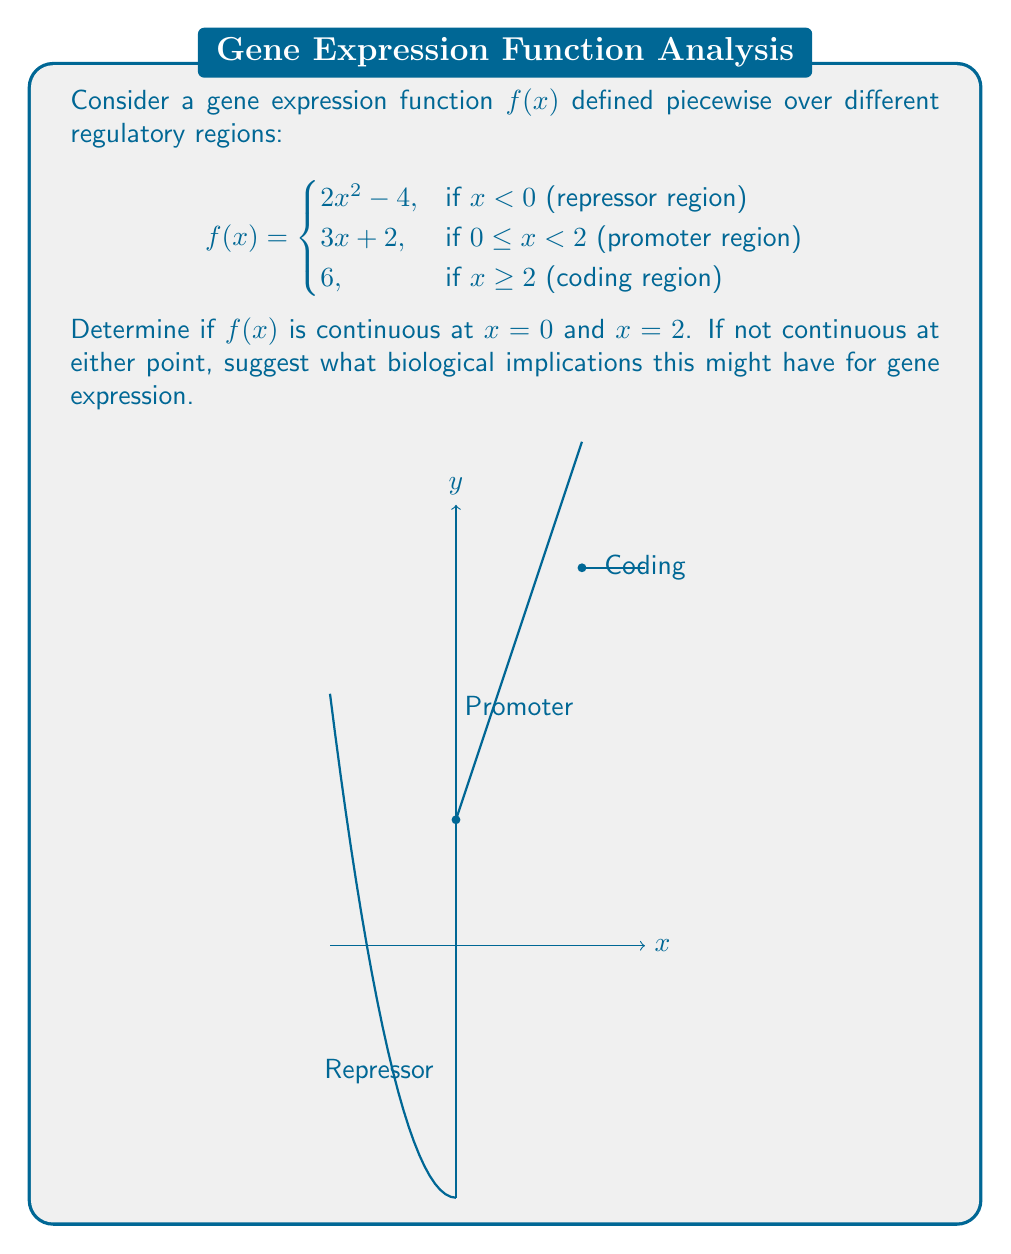Give your solution to this math problem. To determine continuity at $x = 0$ and $x = 2$, we need to check three conditions at each point:
1. The function is defined at the point
2. The limit of the function exists as we approach the point from both sides
3. The limit equals the function value at that point

For $x = 0$:
1. $f(0)$ is defined: $f(0) = 3(0) + 2 = 2$
2. Left limit: $\lim_{x \to 0^-} f(x) = \lim_{x \to 0^-} (2x^2 - 4) = -4$
   Right limit: $\lim_{x \to 0^+} f(x) = \lim_{x \to 0^+} (3x + 2) = 2$
3. The left limit $\neq$ right limit, so the limit doesn't exist at $x = 0$

Therefore, $f(x)$ is not continuous at $x = 0$.

For $x = 2$:
1. $f(2)$ is defined: $f(2) = 6$
2. Left limit: $\lim_{x \to 2^-} f(x) = \lim_{x \to 2^-} (3x + 2) = 8$
   Right limit: $\lim_{x \to 2^+} f(x) = \lim_{x \to 2^+} 6 = 6$
3. The left limit $\neq$ right limit, so the limit doesn't exist at $x = 2$

Therefore, $f(x)$ is not continuous at $x = 2$.

Biological implications:
The discontinuity at $x = 0$ suggests an abrupt change in gene expression as the regulatory mechanism switches from the repressor to the promoter region. This could indicate a sharp activation of the gene.

The discontinuity at $x = 2$ implies a sudden cap on gene expression as it transitions from the promoter to the coding region. This might represent a maximum expression level or a regulatory checkpoint in the gene expression process.
Answer: Not continuous at $x = 0$ or $x = 2$. Implies abrupt changes in gene expression at regulatory transitions. 